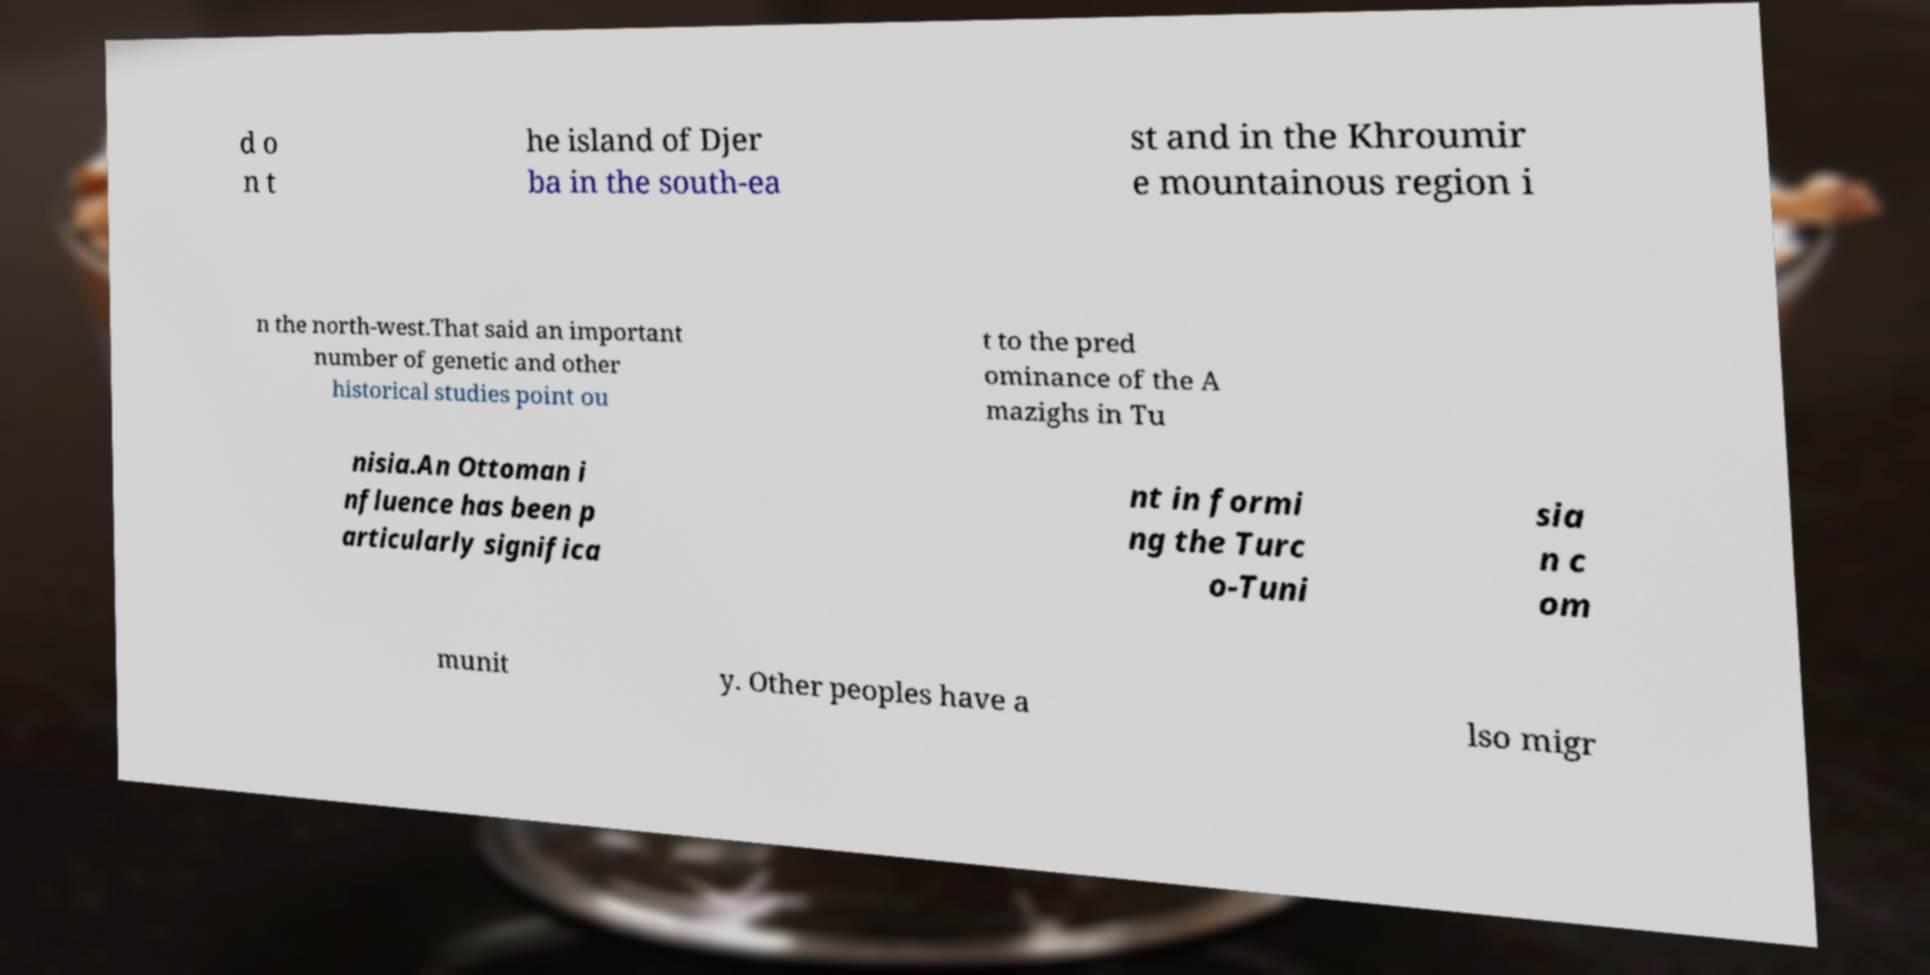What messages or text are displayed in this image? I need them in a readable, typed format. d o n t he island of Djer ba in the south-ea st and in the Khroumir e mountainous region i n the north-west.That said an important number of genetic and other historical studies point ou t to the pred ominance of the A mazighs in Tu nisia.An Ottoman i nfluence has been p articularly significa nt in formi ng the Turc o-Tuni sia n c om munit y. Other peoples have a lso migr 